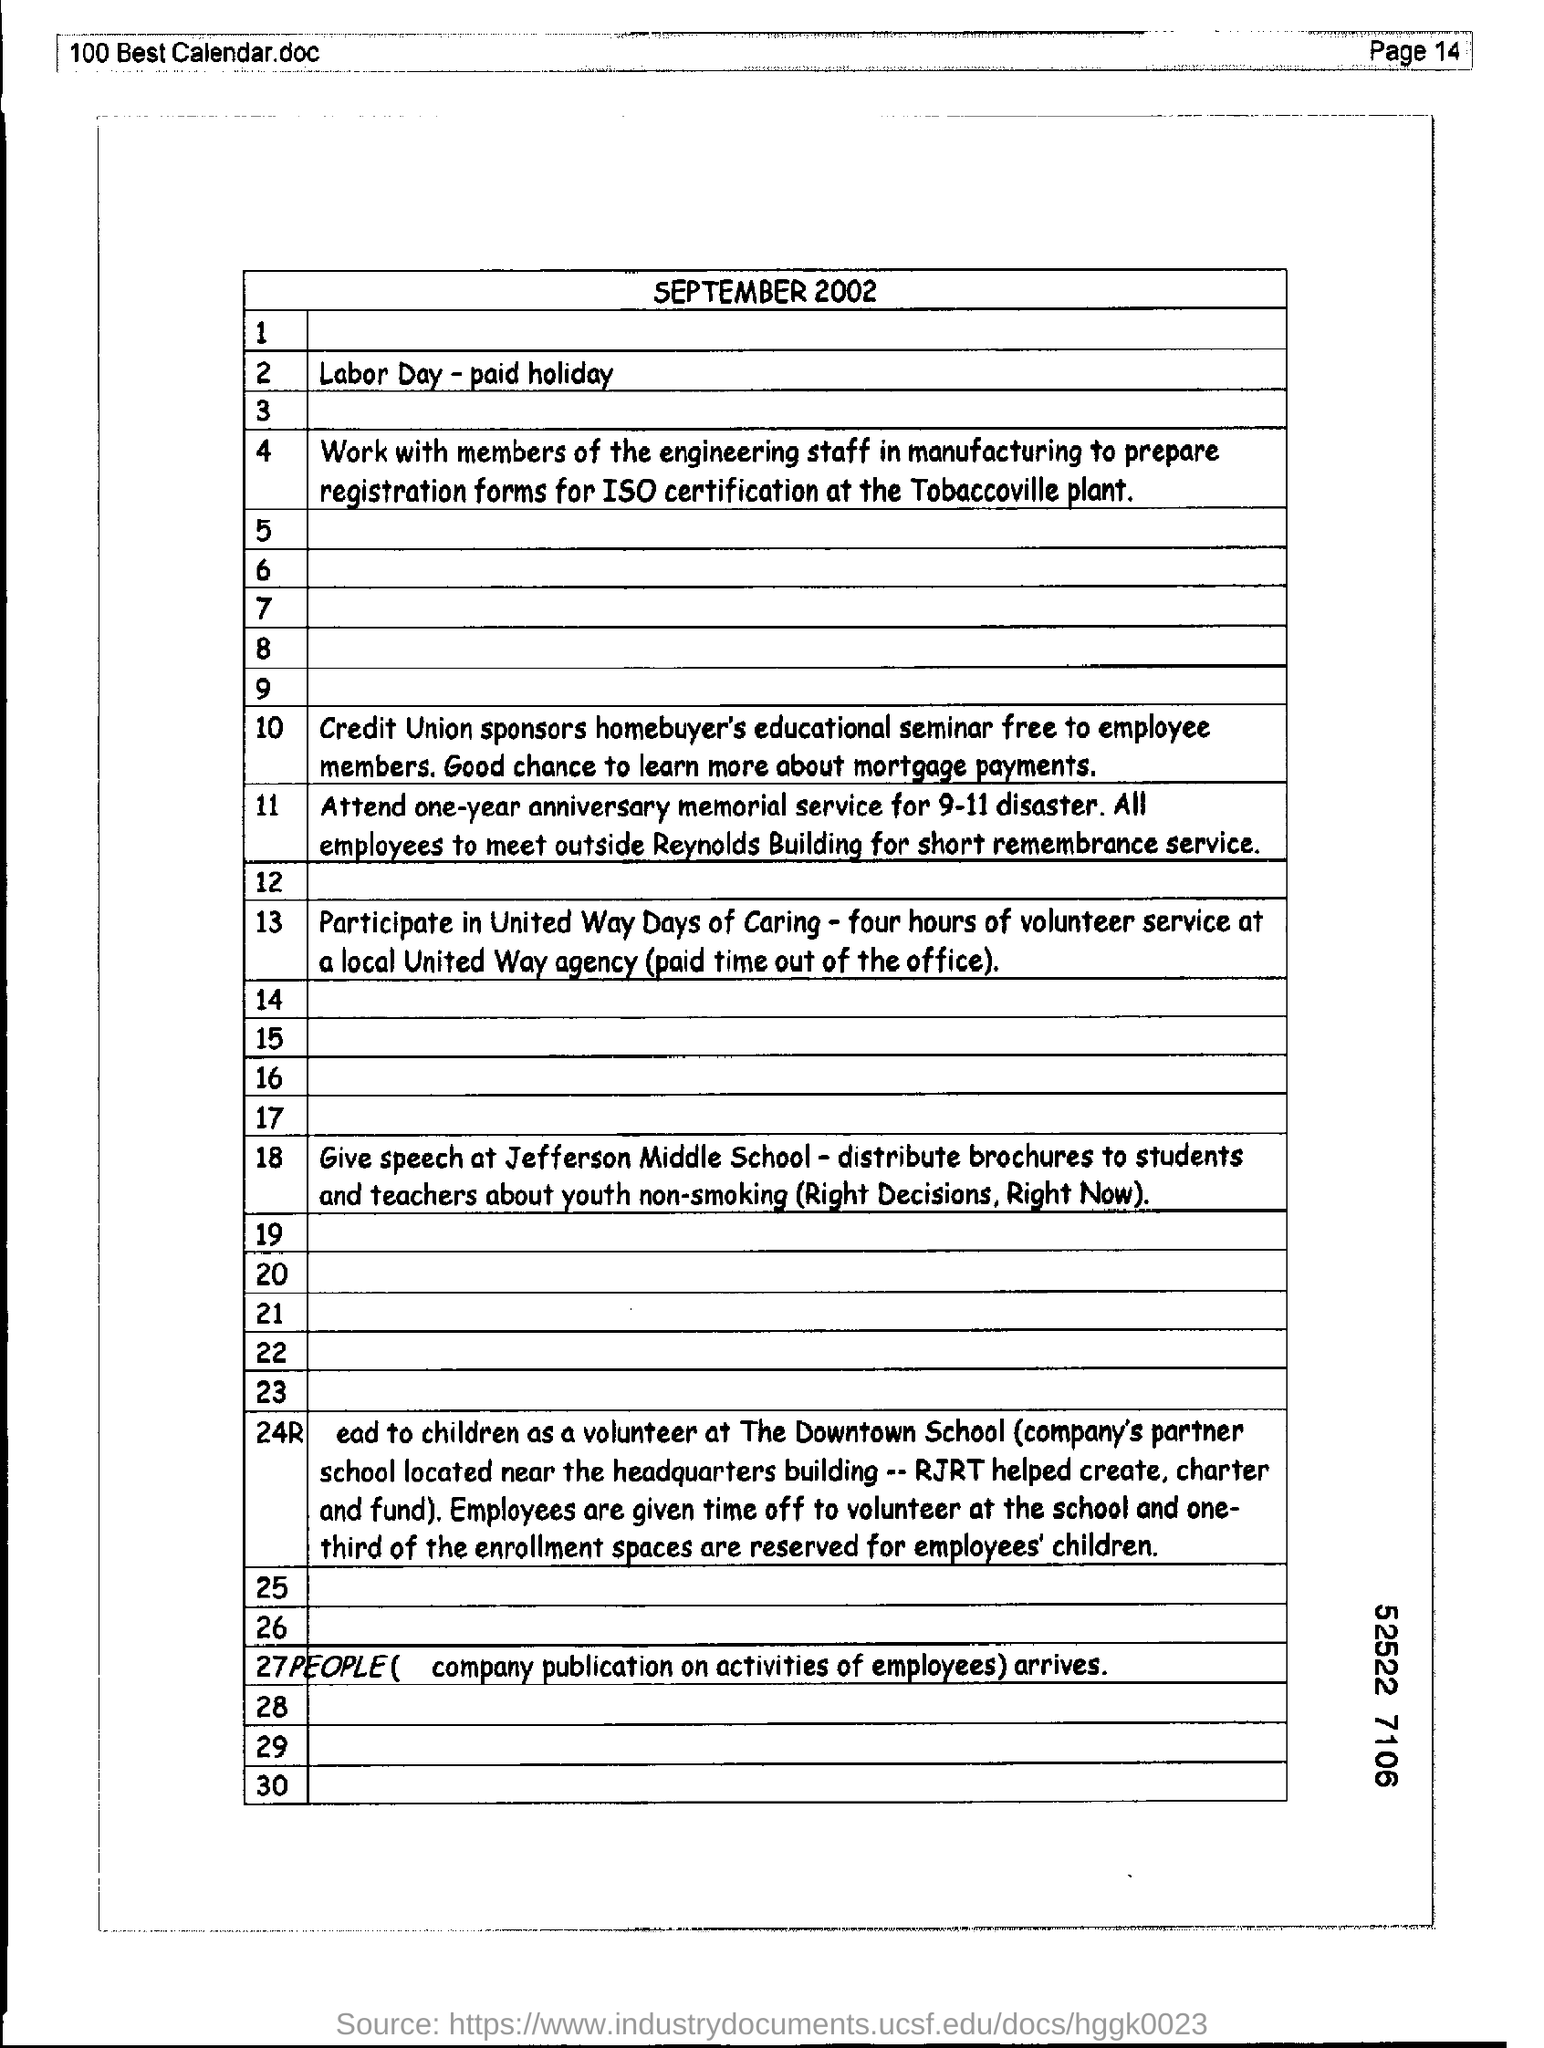Give some essential details in this illustration. It is necessary to mention the page number at the top right corner of the page as stated on page 14. 